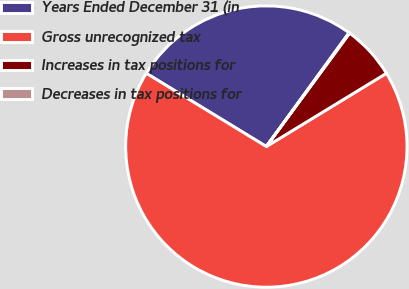Convert chart to OTSL. <chart><loc_0><loc_0><loc_500><loc_500><pie_chart><fcel>Years Ended December 31 (in<fcel>Gross unrecognized tax<fcel>Increases in tax positions for<fcel>Decreases in tax positions for<nl><fcel>26.28%<fcel>67.43%<fcel>6.2%<fcel>0.08%<nl></chart> 